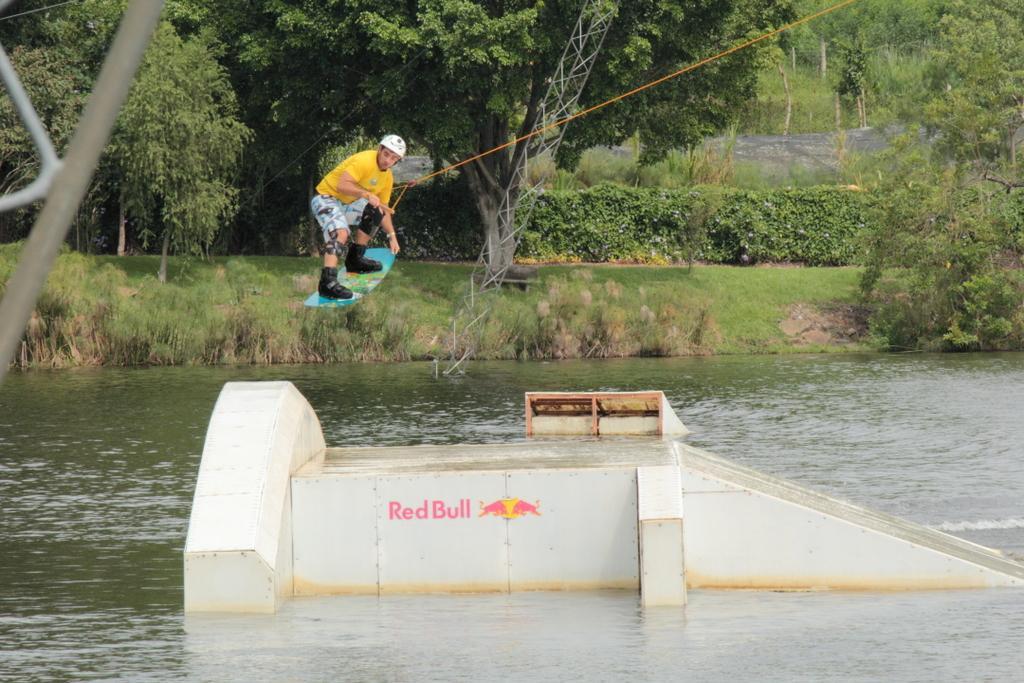Please provide a concise description of this image. To the bottom of the image there is water. In the middle of the water there is a white wall with a slope. And on the wall there is a red bull written on it. In the middle of the image there is a man with yellow t-shirt and wearing the skateboard to his legs and holding the rope in his hands. Behind him in the background there are many trees and on the ground there is a grass. And also there is a tower in the water. 